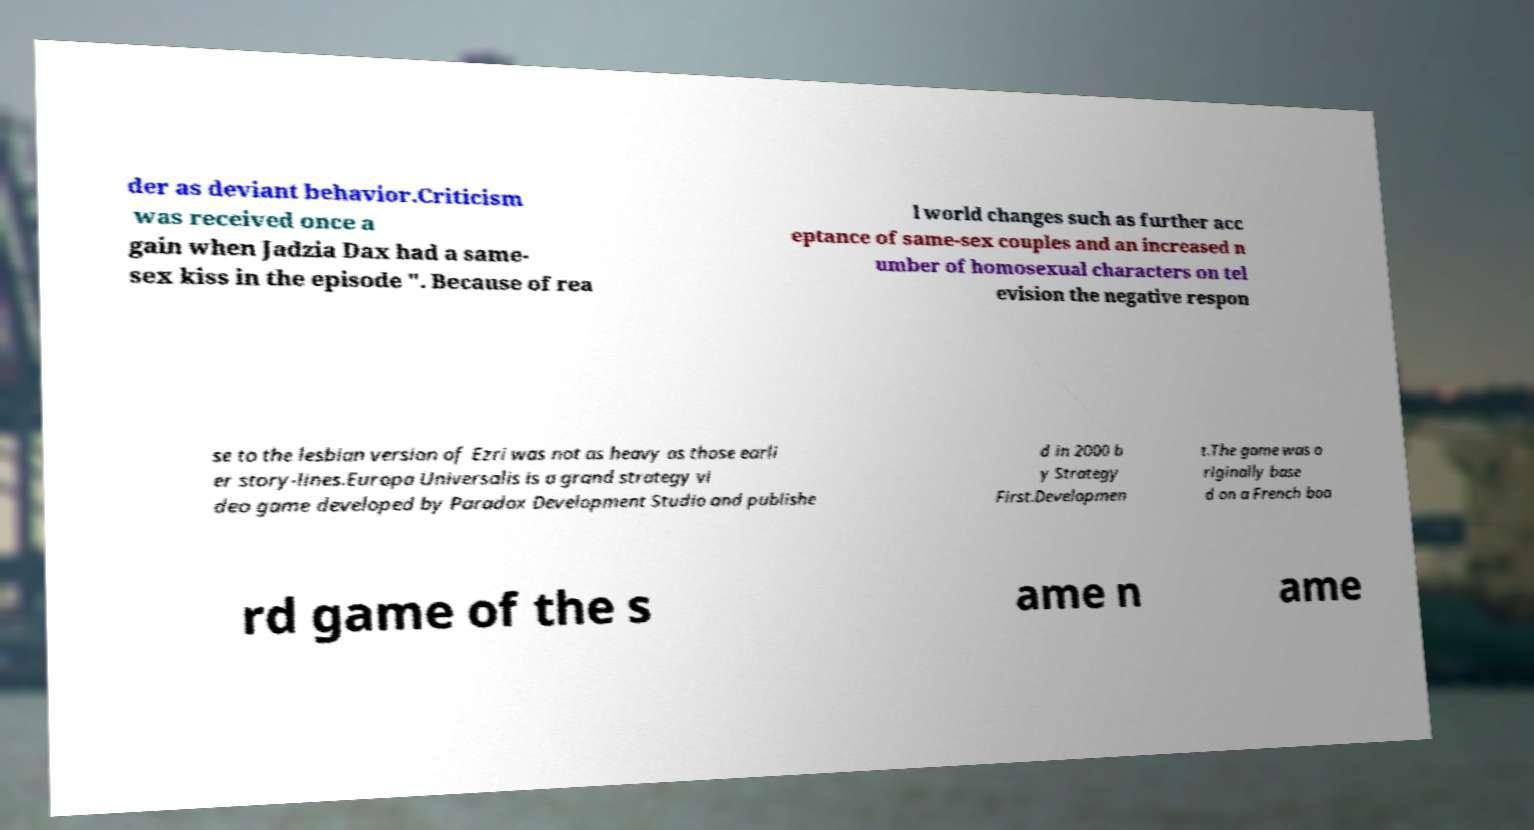What messages or text are displayed in this image? I need them in a readable, typed format. der as deviant behavior.Criticism was received once a gain when Jadzia Dax had a same- sex kiss in the episode ". Because of rea l world changes such as further acc eptance of same-sex couples and an increased n umber of homosexual characters on tel evision the negative respon se to the lesbian version of Ezri was not as heavy as those earli er story-lines.Europa Universalis is a grand strategy vi deo game developed by Paradox Development Studio and publishe d in 2000 b y Strategy First.Developmen t.The game was o riginally base d on a French boa rd game of the s ame n ame 